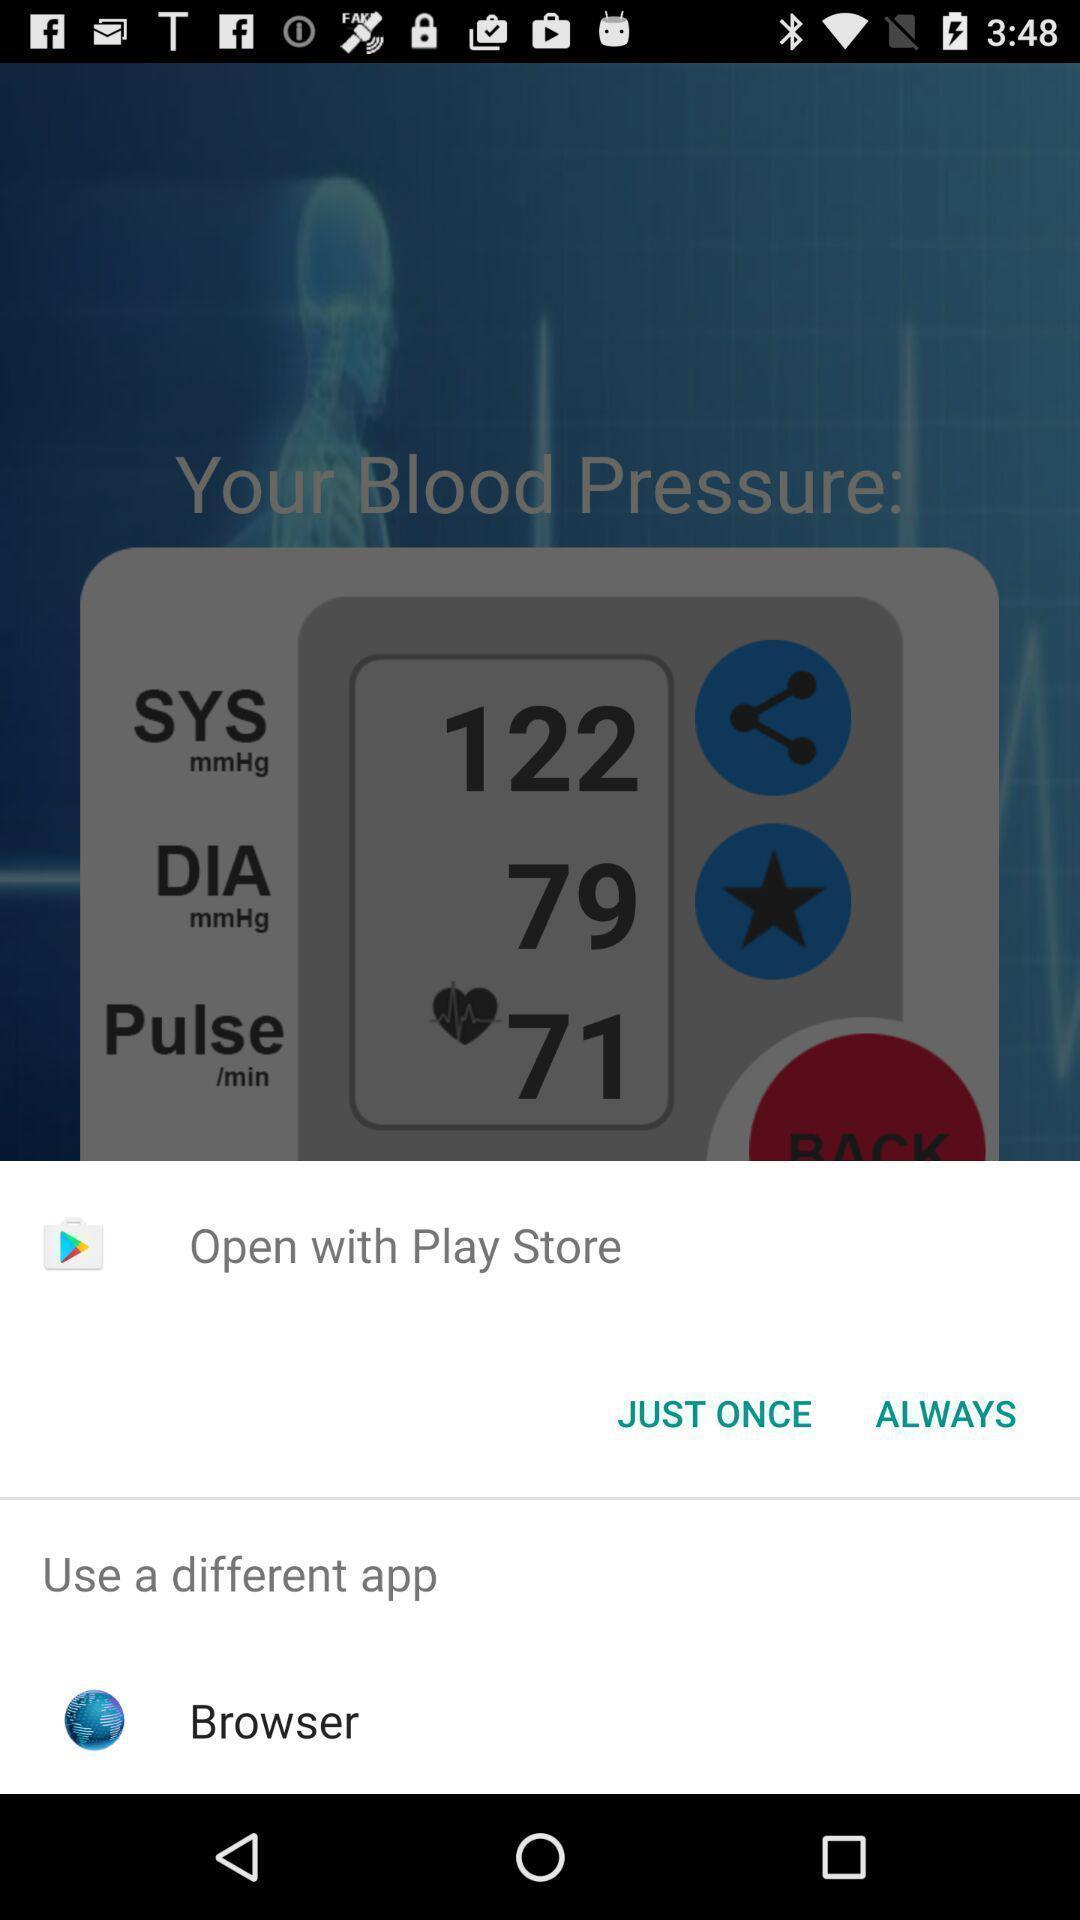Provide a detailed account of this screenshot. Pop-up to open app via different browsers. 